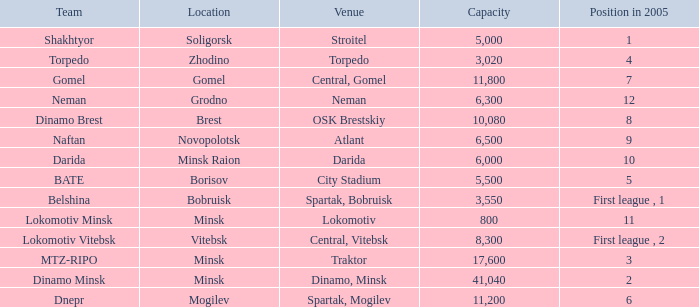Are you able to disclose the site that had the standing in 2005 of 8? OSK Brestskiy. 